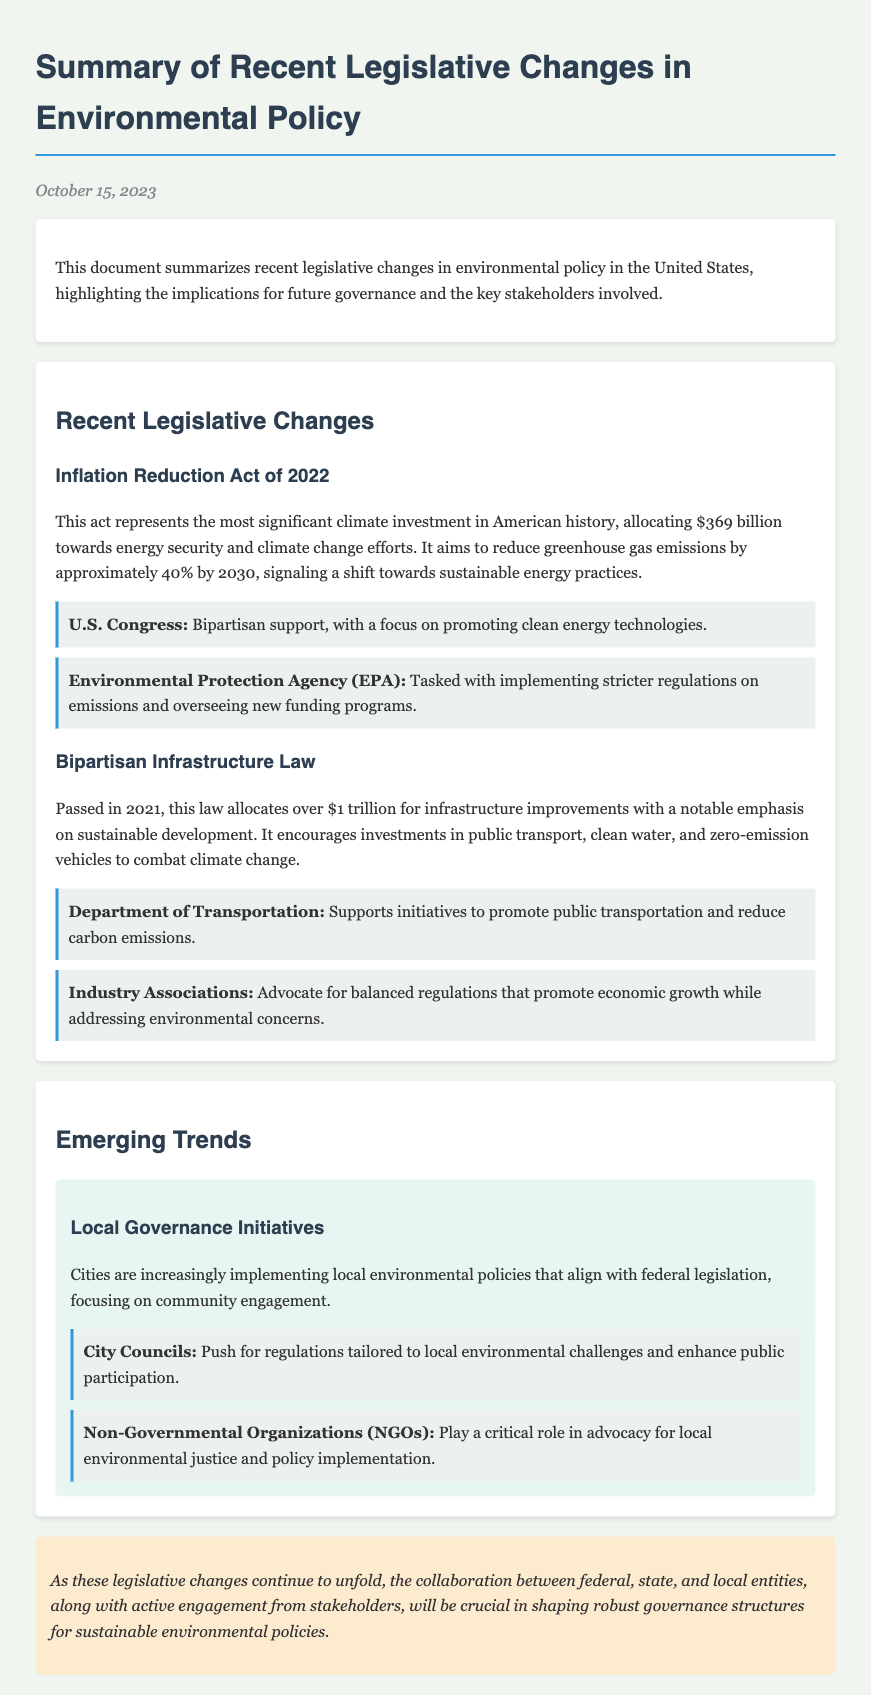What is the date of the document? The date mentioned at the top of the document indicates when the summary was created.
Answer: October 15, 2023 What is the main focus of the Inflation Reduction Act? The Act is aimed at promoting sustainable energy practices and reducing greenhouse gas emissions.
Answer: Energy security and climate change efforts How much funding is allocated in the Bipartisan Infrastructure Law? The document specifies the total amount designated for infrastructure improvements within this law.
Answer: Over $1 trillion Which key agency is responsible for implementing stricter emissions regulations? The document names the agency tasked with overseeing new funding programs related to emissions.
Answer: Environmental Protection Agency What is a significant trend mentioned in local governance? The document discusses a trend where local policies align with federal legislation for environmental issues.
Answer: Local environmental policies Who advocates for balanced regulations regarding environmental practices? The document identifies an organization that supports economic growth while addressing environmental concerns.
Answer: Industry Associations What is the target percentage for greenhouse gas emissions reduction by 2030 as per the Inflation Reduction Act? The document indicates the specific emissions reduction goal set by the Act.
Answer: Approximately 40% What role do NGOs play according to the document? The document outlines the involvement of NGOs in local environmental justice initiatives and policy implementation.
Answer: Advocacy for local environmental justice 